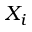Convert formula to latex. <formula><loc_0><loc_0><loc_500><loc_500>X _ { i }</formula> 